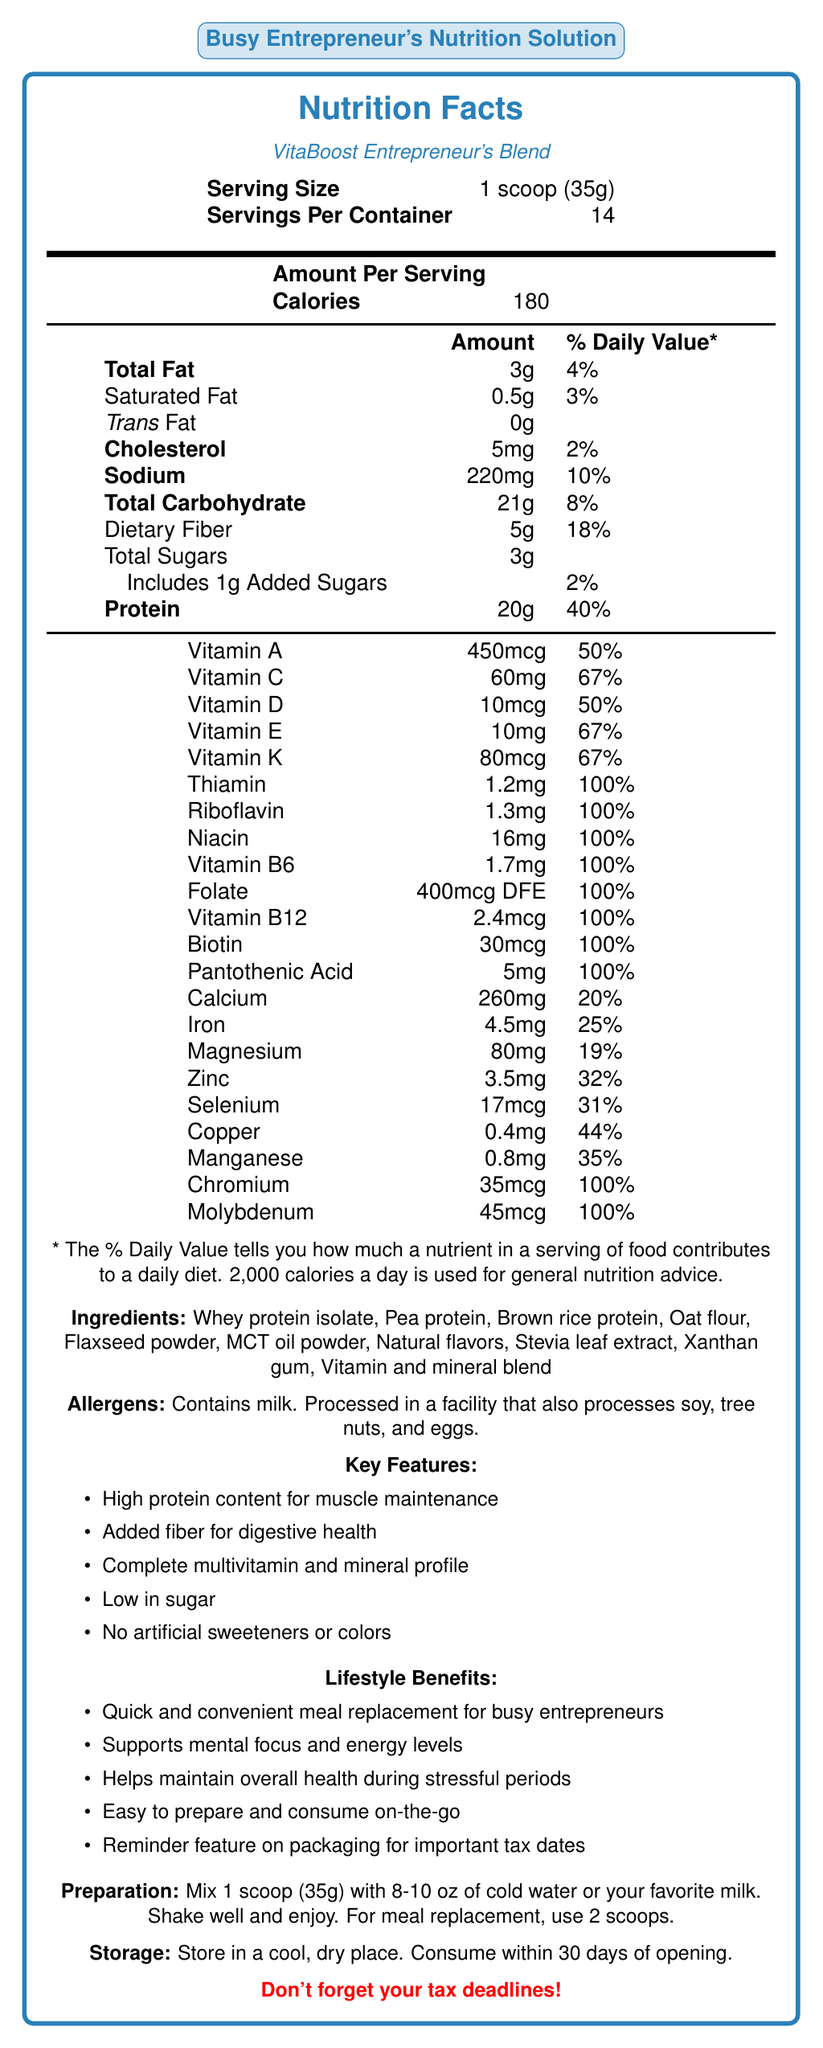What is the serving size of VitaBoost Entrepreneur's Blend? The document lists the serving size of VitaBoost Entrepreneur's Blend as "1 scoop (35g)."
Answer: 1 scoop (35g) How many servings are there per container? According to the document, there are 14 servings per container.
Answer: 14 How many grams of protein are in one serving? The document states that each serving has 20 grams of protein.
Answer: 20g What percentage of the daily value for Vitamin C does one serving provide? The document shows that one serving of the shake provides 67% of the daily value for Vitamin C.
Answer: 67% What are the preparation instructions for this meal replacement shake? The preparation instructions specify to mix 1 scoop with 8-10 oz of cold water or milk, shake well, and take 2 scoops for a meal replacement.
Answer: Mix 1 scoop (35g) with 8-10 oz of cold water or your favorite milk. Shake well and enjoy. For meal replacement, use 2 scoops. How much cholesterol is in one serving? The document lists 5 mg of cholesterol per serving.
Answer: 5mg Which of the following is a feature of this meal replacement shake? A. Contains artificial sweeteners B. High protein content for muscle maintenance C. Low in fat The document lists "High protein content for muscle maintenance" as one of the key features.
Answer: B What allergens does this product contain? The document states that the product contains milk and is processed in a facility that handles soy, tree nuts, and eggs.
Answer: Contains milk. Processed in a facility that also processes soy, tree nuts, and eggs. How many calories are there per serving? The document indicates that there are 180 calories per serving.
Answer: 180 What is the total amount of carbohydrates per serving? According to the document, each serving contains 21 grams of carbohydrates.
Answer: 21g Which of the following vitamins provides 100% of the daily value per serving? A. Vitamin A B. Vitamin C C. Vitamin B12 D. Vitamin D The document lists Vitamin B12 as providing 100% of the daily value per serving.
Answer: C Does this product support mental focus and energy levels? The document lists as a lifestyle benefit that the product supports mental focus and energy levels.
Answer: Yes Summarize the main benefits of VitaBoost Entrepreneur's Blend. The summary captures the key features and lifestyle benefits mentioned in the document.
Answer: VitaBoost Entrepreneur's Blend provides high protein content for muscle maintenance, added fiber for digestive health, a complete multivitamin and mineral profile, and is low in sugar without artificial sweeteners or colors. It is designed for quick and convenient meal replacement for busy entrepreneurs, supporting mental focus, energy levels, and overall health during stressful periods. It also includes a reminder feature on the packaging for important tax dates. How long should you consume the product after opening? The storage instructions indicate to consume the product within 30 days of opening.
Answer: 30 days Is the product low in sugar? The document lists low sugar as a key feature.
Answer: Yes What is the iron content per serving in terms of the daily value percentage? The document states that each serving provides 25% of the daily value for iron.
Answer: 25% What are the main ingredients included in the VitaBoost Entrepreneur's Blend? The ingredients list contains all the mentioned components.
Answer: Whey protein isolate, Pea protein, Brown rice protein, Oat flour, Flaxseed powder, MCT oil powder, Natural flavors, Stevia leaf extract, Xanthan gum, Vitamin and mineral blend What is the tax date reminder feature mentioned in the document? The document only mentions a reminder feature for tax dates on the packaging, but does not provide details on how it works or what specific dates are included.
Answer: I don't know 